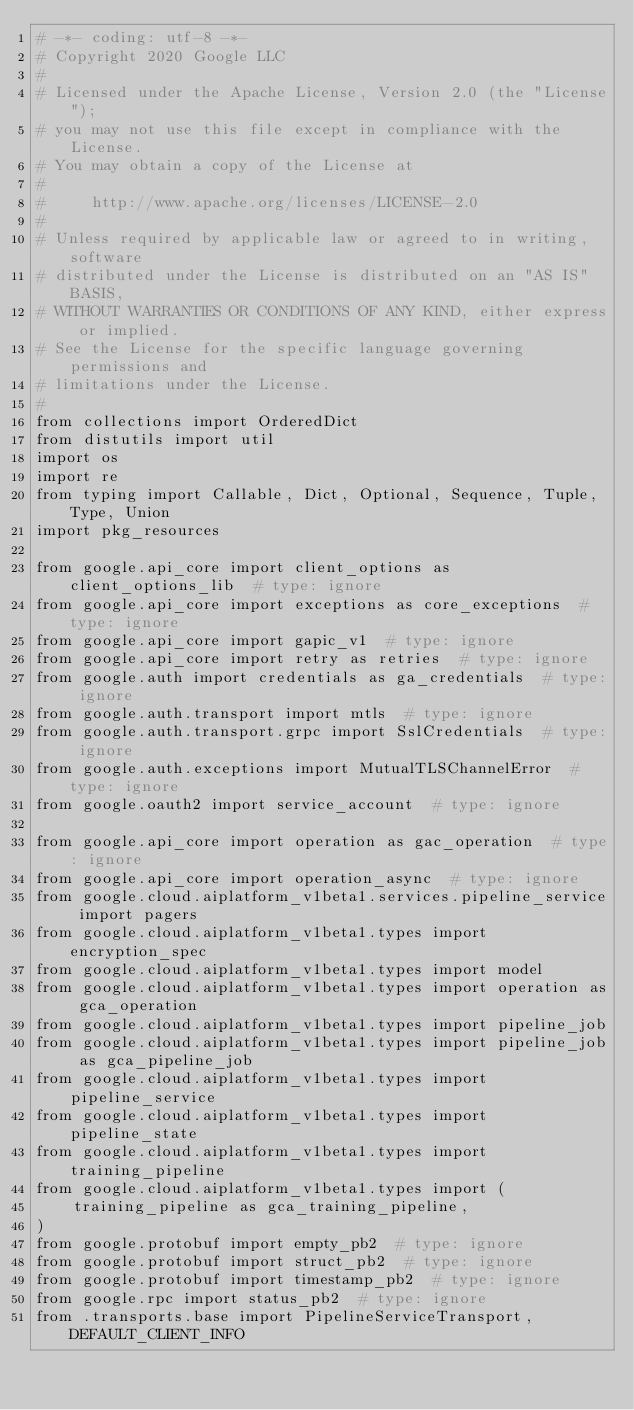<code> <loc_0><loc_0><loc_500><loc_500><_Python_># -*- coding: utf-8 -*-
# Copyright 2020 Google LLC
#
# Licensed under the Apache License, Version 2.0 (the "License");
# you may not use this file except in compliance with the License.
# You may obtain a copy of the License at
#
#     http://www.apache.org/licenses/LICENSE-2.0
#
# Unless required by applicable law or agreed to in writing, software
# distributed under the License is distributed on an "AS IS" BASIS,
# WITHOUT WARRANTIES OR CONDITIONS OF ANY KIND, either express or implied.
# See the License for the specific language governing permissions and
# limitations under the License.
#
from collections import OrderedDict
from distutils import util
import os
import re
from typing import Callable, Dict, Optional, Sequence, Tuple, Type, Union
import pkg_resources

from google.api_core import client_options as client_options_lib  # type: ignore
from google.api_core import exceptions as core_exceptions  # type: ignore
from google.api_core import gapic_v1  # type: ignore
from google.api_core import retry as retries  # type: ignore
from google.auth import credentials as ga_credentials  # type: ignore
from google.auth.transport import mtls  # type: ignore
from google.auth.transport.grpc import SslCredentials  # type: ignore
from google.auth.exceptions import MutualTLSChannelError  # type: ignore
from google.oauth2 import service_account  # type: ignore

from google.api_core import operation as gac_operation  # type: ignore
from google.api_core import operation_async  # type: ignore
from google.cloud.aiplatform_v1beta1.services.pipeline_service import pagers
from google.cloud.aiplatform_v1beta1.types import encryption_spec
from google.cloud.aiplatform_v1beta1.types import model
from google.cloud.aiplatform_v1beta1.types import operation as gca_operation
from google.cloud.aiplatform_v1beta1.types import pipeline_job
from google.cloud.aiplatform_v1beta1.types import pipeline_job as gca_pipeline_job
from google.cloud.aiplatform_v1beta1.types import pipeline_service
from google.cloud.aiplatform_v1beta1.types import pipeline_state
from google.cloud.aiplatform_v1beta1.types import training_pipeline
from google.cloud.aiplatform_v1beta1.types import (
    training_pipeline as gca_training_pipeline,
)
from google.protobuf import empty_pb2  # type: ignore
from google.protobuf import struct_pb2  # type: ignore
from google.protobuf import timestamp_pb2  # type: ignore
from google.rpc import status_pb2  # type: ignore
from .transports.base import PipelineServiceTransport, DEFAULT_CLIENT_INFO</code> 